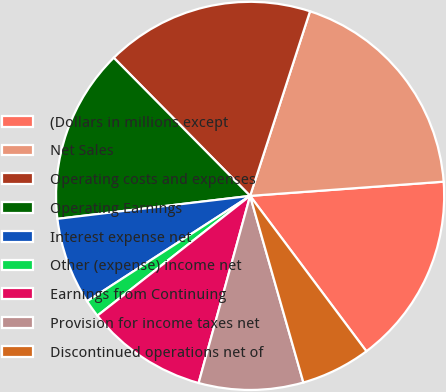<chart> <loc_0><loc_0><loc_500><loc_500><pie_chart><fcel>(Dollars in millions except<fcel>Net Sales<fcel>Operating costs and expenses<fcel>Operating Earnings<fcel>Interest expense net<fcel>Other (expense) income net<fcel>Earnings from Continuing<fcel>Provision for income taxes net<fcel>Discontinued operations net of<nl><fcel>15.94%<fcel>18.84%<fcel>17.39%<fcel>14.49%<fcel>7.25%<fcel>1.45%<fcel>10.14%<fcel>8.7%<fcel>5.8%<nl></chart> 